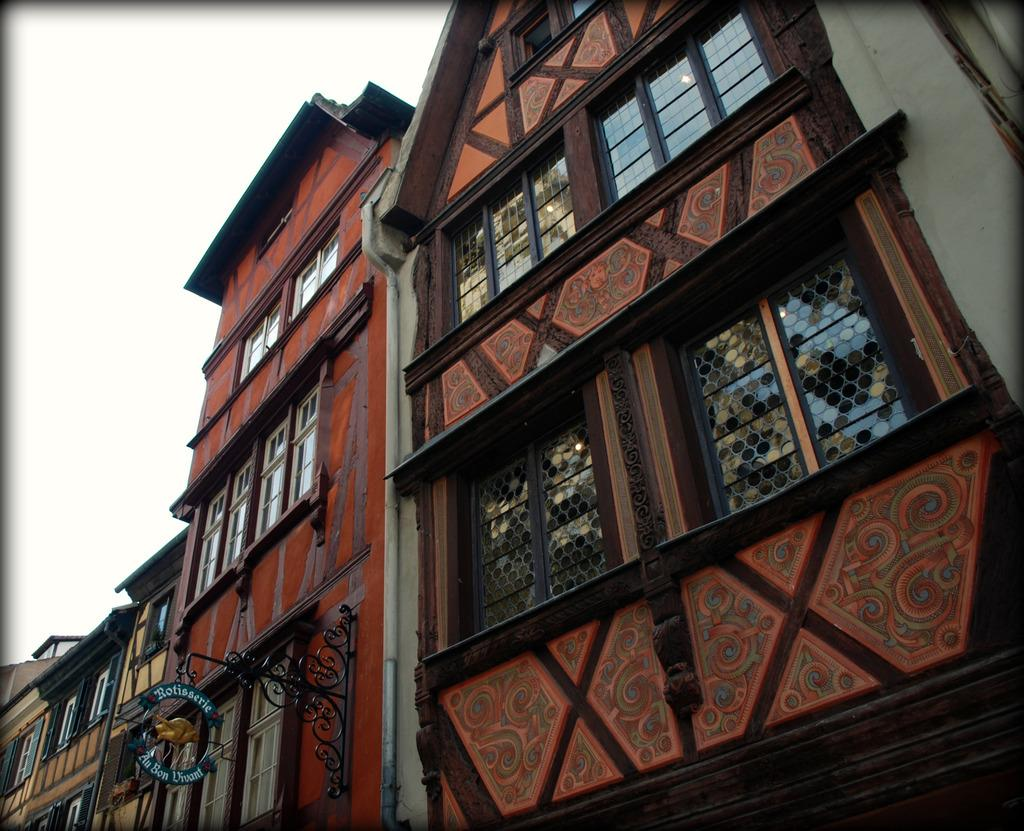What type of structures can be seen in the image? There are buildings in the image. Is there any signage or identification in the image? Yes, there is a name board in the image. What can be seen in the background of the image? The sky is visible in the background of the image. Are there any horses grazing in the garden in the image? There is no garden or horses present in the image. 